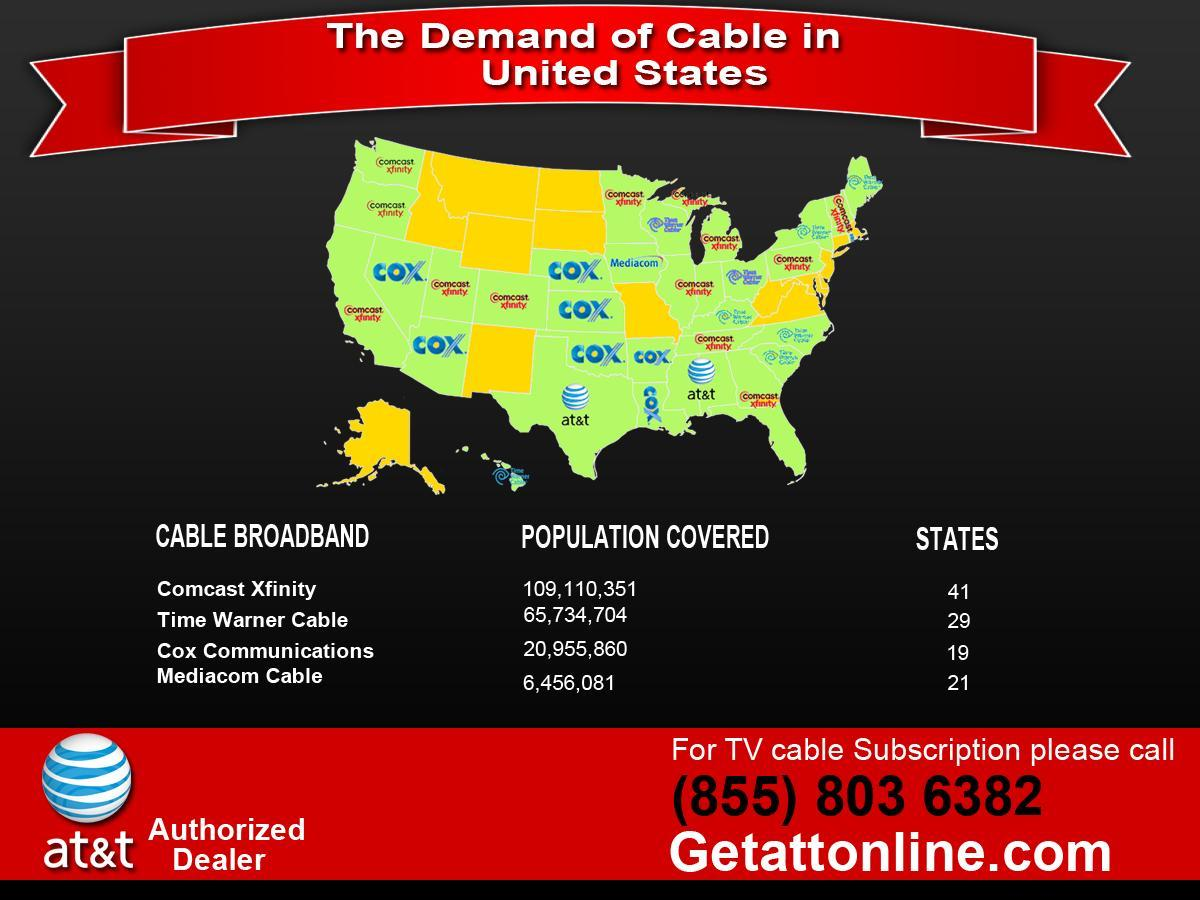How many states on the map have Comcast Xfinity as cable broadband provider ?
Answer the question with a short phrase. 13 What is the total population covered by the four broadband cable companies excluding at&t? 202,256,996 How many states on the map have have COX Communications as the cable broadband provider? 7 How many states on the map have at&t as the cable broadband provider ? 2 How many cable broadband providers are there in US? 5 